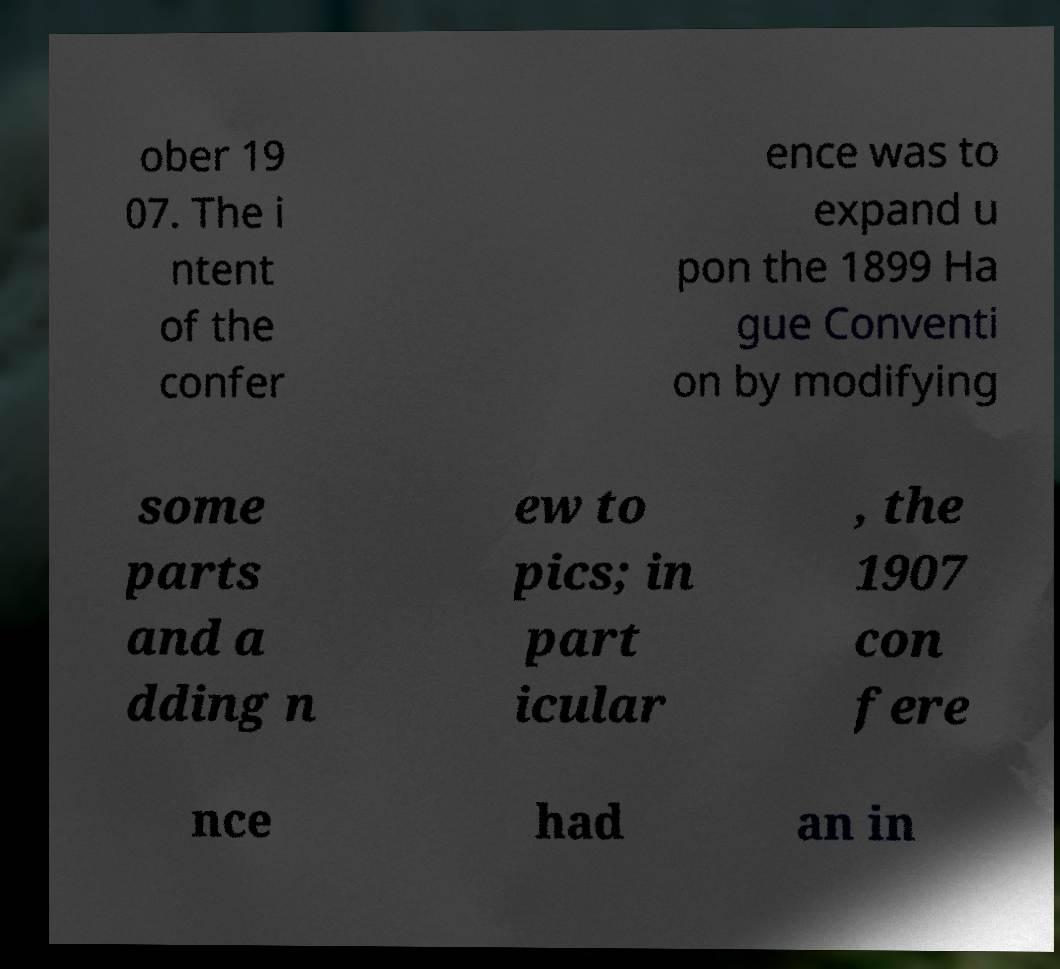Please identify and transcribe the text found in this image. ober 19 07. The i ntent of the confer ence was to expand u pon the 1899 Ha gue Conventi on by modifying some parts and a dding n ew to pics; in part icular , the 1907 con fere nce had an in 